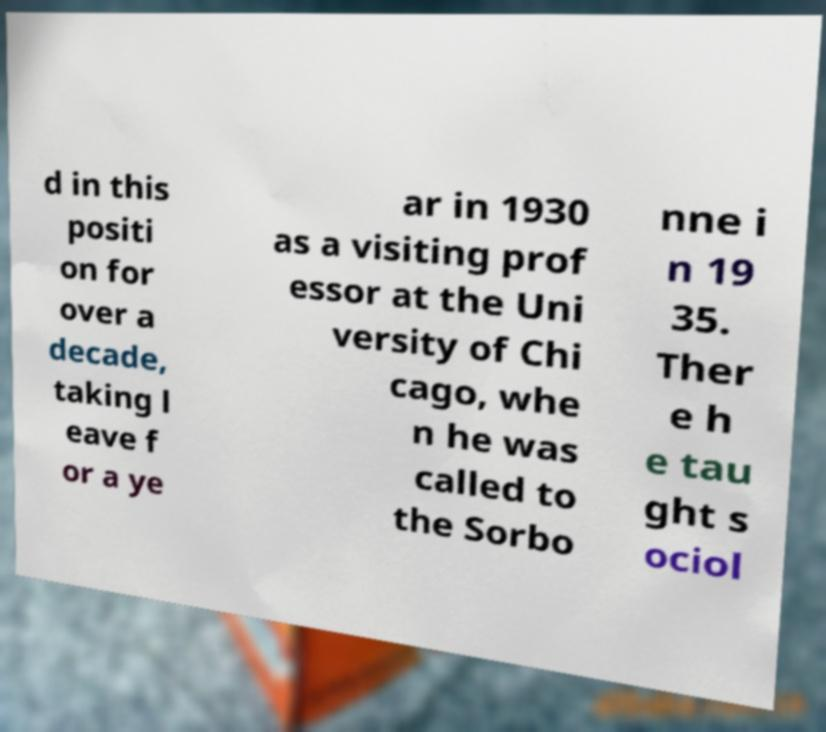Can you accurately transcribe the text from the provided image for me? d in this positi on for over a decade, taking l eave f or a ye ar in 1930 as a visiting prof essor at the Uni versity of Chi cago, whe n he was called to the Sorbo nne i n 19 35. Ther e h e tau ght s ociol 